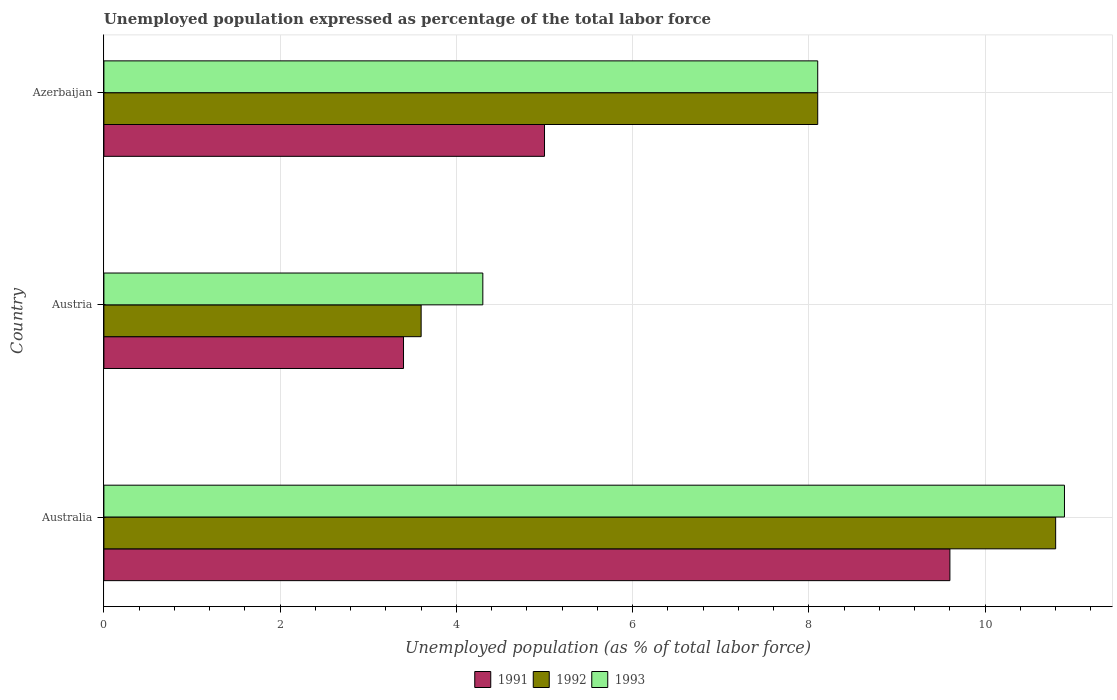How many groups of bars are there?
Provide a succinct answer. 3. Are the number of bars per tick equal to the number of legend labels?
Keep it short and to the point. Yes. Are the number of bars on each tick of the Y-axis equal?
Offer a very short reply. Yes. How many bars are there on the 1st tick from the bottom?
Offer a terse response. 3. What is the label of the 3rd group of bars from the top?
Make the answer very short. Australia. In how many cases, is the number of bars for a given country not equal to the number of legend labels?
Make the answer very short. 0. What is the unemployment in in 1993 in Austria?
Offer a terse response. 4.3. Across all countries, what is the maximum unemployment in in 1991?
Provide a short and direct response. 9.6. Across all countries, what is the minimum unemployment in in 1991?
Ensure brevity in your answer.  3.4. In which country was the unemployment in in 1991 maximum?
Offer a terse response. Australia. What is the total unemployment in in 1993 in the graph?
Provide a short and direct response. 23.3. What is the difference between the unemployment in in 1992 in Australia and that in Austria?
Give a very brief answer. 7.2. What is the difference between the unemployment in in 1993 in Azerbaijan and the unemployment in in 1992 in Austria?
Your answer should be very brief. 4.5. What is the average unemployment in in 1992 per country?
Provide a succinct answer. 7.5. What is the difference between the unemployment in in 1991 and unemployment in in 1993 in Australia?
Your response must be concise. -1.3. In how many countries, is the unemployment in in 1992 greater than 8.4 %?
Provide a short and direct response. 1. What is the ratio of the unemployment in in 1993 in Australia to that in Austria?
Give a very brief answer. 2.53. What is the difference between the highest and the second highest unemployment in in 1993?
Give a very brief answer. 2.8. What is the difference between the highest and the lowest unemployment in in 1991?
Offer a terse response. 6.2. Is the sum of the unemployment in in 1991 in Australia and Azerbaijan greater than the maximum unemployment in in 1992 across all countries?
Make the answer very short. Yes. What is the difference between two consecutive major ticks on the X-axis?
Provide a short and direct response. 2. Does the graph contain any zero values?
Give a very brief answer. No. Does the graph contain grids?
Provide a short and direct response. Yes. How many legend labels are there?
Your answer should be compact. 3. How are the legend labels stacked?
Your answer should be compact. Horizontal. What is the title of the graph?
Give a very brief answer. Unemployed population expressed as percentage of the total labor force. Does "1977" appear as one of the legend labels in the graph?
Offer a very short reply. No. What is the label or title of the X-axis?
Offer a very short reply. Unemployed population (as % of total labor force). What is the Unemployed population (as % of total labor force) in 1991 in Australia?
Your answer should be very brief. 9.6. What is the Unemployed population (as % of total labor force) of 1992 in Australia?
Your answer should be compact. 10.8. What is the Unemployed population (as % of total labor force) in 1993 in Australia?
Provide a succinct answer. 10.9. What is the Unemployed population (as % of total labor force) in 1991 in Austria?
Your answer should be very brief. 3.4. What is the Unemployed population (as % of total labor force) in 1992 in Austria?
Provide a short and direct response. 3.6. What is the Unemployed population (as % of total labor force) of 1993 in Austria?
Provide a succinct answer. 4.3. What is the Unemployed population (as % of total labor force) in 1991 in Azerbaijan?
Provide a short and direct response. 5. What is the Unemployed population (as % of total labor force) of 1992 in Azerbaijan?
Ensure brevity in your answer.  8.1. What is the Unemployed population (as % of total labor force) of 1993 in Azerbaijan?
Make the answer very short. 8.1. Across all countries, what is the maximum Unemployed population (as % of total labor force) of 1991?
Offer a very short reply. 9.6. Across all countries, what is the maximum Unemployed population (as % of total labor force) of 1992?
Provide a short and direct response. 10.8. Across all countries, what is the maximum Unemployed population (as % of total labor force) of 1993?
Ensure brevity in your answer.  10.9. Across all countries, what is the minimum Unemployed population (as % of total labor force) of 1991?
Ensure brevity in your answer.  3.4. Across all countries, what is the minimum Unemployed population (as % of total labor force) in 1992?
Ensure brevity in your answer.  3.6. Across all countries, what is the minimum Unemployed population (as % of total labor force) in 1993?
Your response must be concise. 4.3. What is the total Unemployed population (as % of total labor force) in 1993 in the graph?
Keep it short and to the point. 23.3. What is the difference between the Unemployed population (as % of total labor force) in 1991 in Australia and that in Austria?
Provide a short and direct response. 6.2. What is the difference between the Unemployed population (as % of total labor force) in 1992 in Australia and that in Austria?
Provide a succinct answer. 7.2. What is the difference between the Unemployed population (as % of total labor force) of 1991 in Australia and that in Azerbaijan?
Give a very brief answer. 4.6. What is the difference between the Unemployed population (as % of total labor force) of 1993 in Australia and that in Azerbaijan?
Ensure brevity in your answer.  2.8. What is the difference between the Unemployed population (as % of total labor force) in 1991 in Austria and that in Azerbaijan?
Offer a terse response. -1.6. What is the difference between the Unemployed population (as % of total labor force) in 1992 in Austria and that in Azerbaijan?
Offer a very short reply. -4.5. What is the difference between the Unemployed population (as % of total labor force) of 1993 in Austria and that in Azerbaijan?
Ensure brevity in your answer.  -3.8. What is the difference between the Unemployed population (as % of total labor force) in 1992 in Australia and the Unemployed population (as % of total labor force) in 1993 in Azerbaijan?
Make the answer very short. 2.7. What is the difference between the Unemployed population (as % of total labor force) in 1991 in Austria and the Unemployed population (as % of total labor force) in 1992 in Azerbaijan?
Offer a terse response. -4.7. What is the difference between the Unemployed population (as % of total labor force) of 1992 in Austria and the Unemployed population (as % of total labor force) of 1993 in Azerbaijan?
Offer a terse response. -4.5. What is the average Unemployed population (as % of total labor force) of 1991 per country?
Your answer should be very brief. 6. What is the average Unemployed population (as % of total labor force) in 1992 per country?
Your answer should be very brief. 7.5. What is the average Unemployed population (as % of total labor force) of 1993 per country?
Provide a succinct answer. 7.77. What is the difference between the Unemployed population (as % of total labor force) of 1991 and Unemployed population (as % of total labor force) of 1992 in Australia?
Offer a terse response. -1.2. What is the difference between the Unemployed population (as % of total labor force) in 1991 and Unemployed population (as % of total labor force) in 1993 in Australia?
Make the answer very short. -1.3. What is the difference between the Unemployed population (as % of total labor force) in 1992 and Unemployed population (as % of total labor force) in 1993 in Australia?
Your answer should be compact. -0.1. What is the difference between the Unemployed population (as % of total labor force) in 1991 and Unemployed population (as % of total labor force) in 1992 in Austria?
Provide a short and direct response. -0.2. What is the difference between the Unemployed population (as % of total labor force) of 1991 and Unemployed population (as % of total labor force) of 1992 in Azerbaijan?
Ensure brevity in your answer.  -3.1. What is the difference between the Unemployed population (as % of total labor force) in 1992 and Unemployed population (as % of total labor force) in 1993 in Azerbaijan?
Your response must be concise. 0. What is the ratio of the Unemployed population (as % of total labor force) of 1991 in Australia to that in Austria?
Give a very brief answer. 2.82. What is the ratio of the Unemployed population (as % of total labor force) in 1993 in Australia to that in Austria?
Make the answer very short. 2.53. What is the ratio of the Unemployed population (as % of total labor force) in 1991 in Australia to that in Azerbaijan?
Offer a terse response. 1.92. What is the ratio of the Unemployed population (as % of total labor force) of 1992 in Australia to that in Azerbaijan?
Your response must be concise. 1.33. What is the ratio of the Unemployed population (as % of total labor force) in 1993 in Australia to that in Azerbaijan?
Provide a succinct answer. 1.35. What is the ratio of the Unemployed population (as % of total labor force) in 1991 in Austria to that in Azerbaijan?
Your answer should be compact. 0.68. What is the ratio of the Unemployed population (as % of total labor force) of 1992 in Austria to that in Azerbaijan?
Keep it short and to the point. 0.44. What is the ratio of the Unemployed population (as % of total labor force) of 1993 in Austria to that in Azerbaijan?
Provide a succinct answer. 0.53. What is the difference between the highest and the second highest Unemployed population (as % of total labor force) of 1992?
Provide a succinct answer. 2.7. What is the difference between the highest and the lowest Unemployed population (as % of total labor force) in 1991?
Your answer should be very brief. 6.2. 